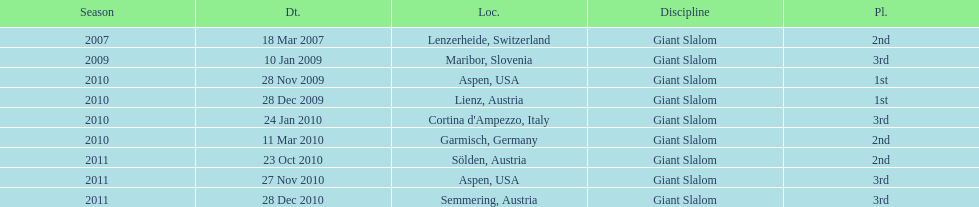Aspen and lienz in 2009 are the only races where this racer got what position? 1st. 